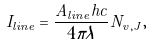Convert formula to latex. <formula><loc_0><loc_0><loc_500><loc_500>I _ { l i n e } = \frac { A _ { l i n e } h c } { 4 \pi \lambda } N _ { v , J } ,</formula> 